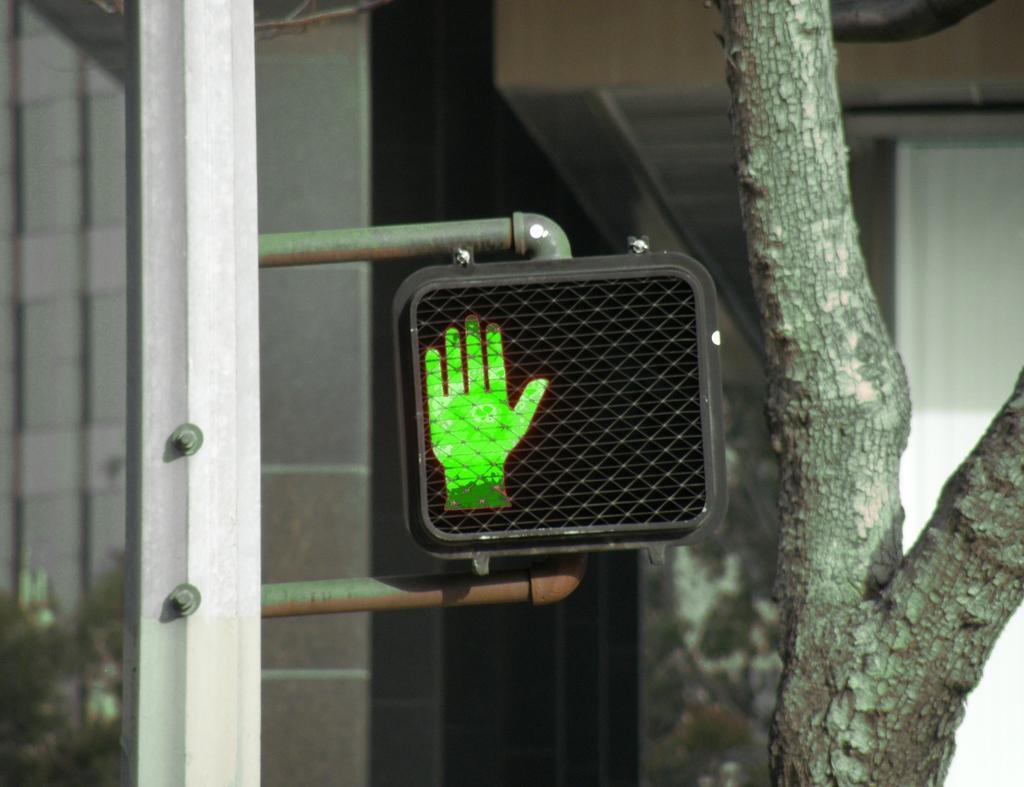In one or two sentences, can you explain what this image depicts? This image is taken outdoors. On the left side of the image there is a pole with a signboard. On the right side of the image there is a tree. In the background there is a wall. 